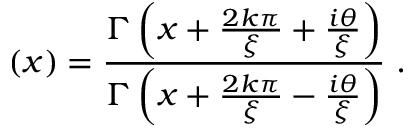Convert formula to latex. <formula><loc_0><loc_0><loc_500><loc_500>\left ( x \right ) = \frac { \Gamma \left ( x + \frac { 2 k \pi } { \xi } + \frac { i \theta } { \xi } \right ) } { \Gamma \left ( x + \frac { 2 k \pi } { \xi } - \frac { i \theta } { \xi } \right ) } \ .</formula> 